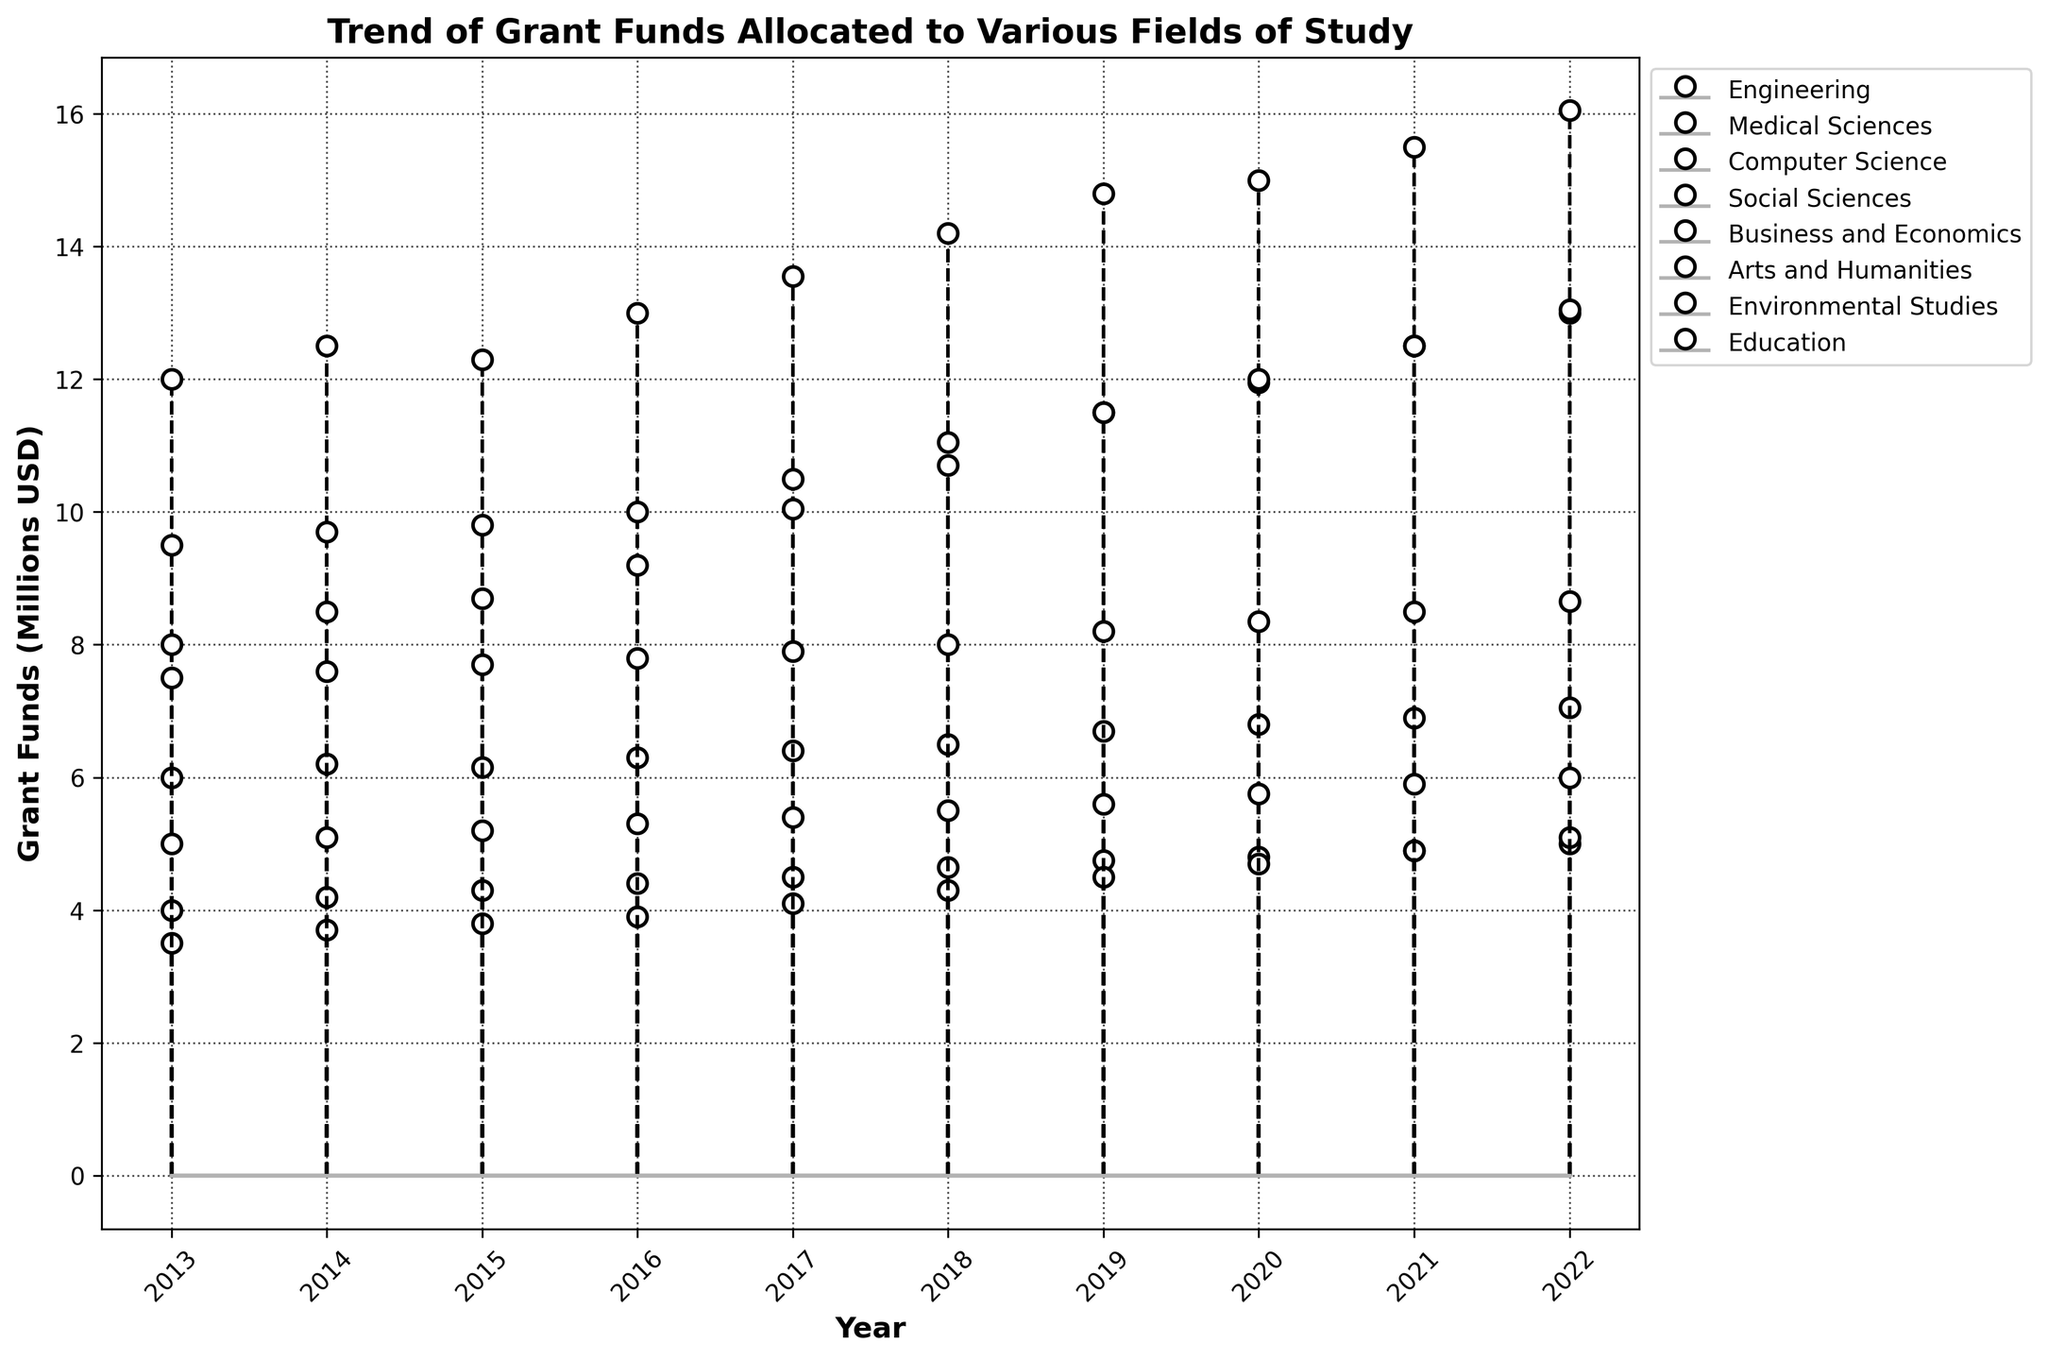What's the title of the figure? The title can be found at the top of the figure. It describes the content and purpose of the plot.
Answer: Trend of Grant Funds Allocated to Various Fields of Study What is the unit of measurement on the y-axis? The y-axis typically shows the quantity being measured, in this case, it is labeled to indicate the units.
Answer: Grant Funds (Millions USD) Which field of study received the highest amount of grant funds in 2022? Look at the endpoints of the stem lines for each field in 2022 and compare their values. The field with the highest endpoint value has the highest funds.
Answer: Engineering How much did the grant funds to Medical Sciences increase between 2013 and 2022? Subtract the value for Medical Sciences in 2013 from the value in 2022 to find the total increase. (13000000 - 9500000)
Answer: 3500000 USD Between 2019 and 2020, which field of study saw the largest increase in grant funds? Calculate the difference in grant funds for each field between 2019 and 2020 and compare them to identify the one with the largest increase.
Answer: Medical Sciences What is the average yearly grant fund allocation to Social Sciences from 2013 to 2022? Sum the Social Sciences grant fund values from 2013 to 2022 and divide by the number of years (10). (6000000 + 6200000 + 6150000 + 6300000 + 6400000 + 6500000 + 6700000 + 6800000 + 6900000 + 7050000) / 10
Answer: 6500000 USD Which years show the most significant increase in grant funds for Computer Science? Compare the yearly values for Computer Science and look for the largest increases from one year to the next. 2014-2015, 2015-2016, and 2017-2018 show notable increases.
Answer: 2017-2018 Did any field of study experience a decrease in grant funds at any point during the decade? Examine the stem lines for each field to see if any year-to-year values decrease. Social Sciences decreased between 2014 and 2015.
Answer: Yes Which field of study has consistently received the least amount of grant funds over the past decade? Compare the overall trends for each field. The one with consistently lower values is the least funded.
Answer: Environmental Studies How do the trends in grant fund allocations to Engineering and Education compare? Observe the stem lines for both fields. Engineering shows a steady increase, whereas Education has a more gradual and consistent increase.
Answer: Engineering increases faster than Education 